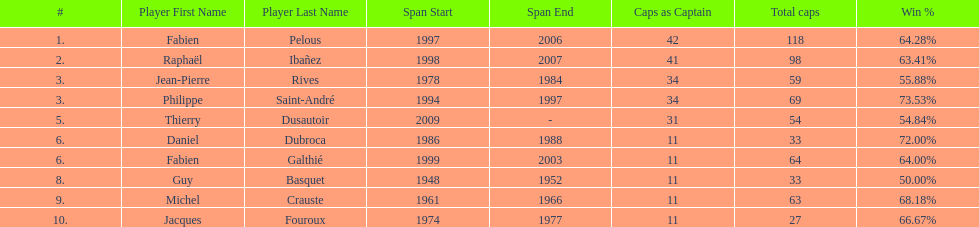Who had the largest win percentage? Philippe Saint-André. Give me the full table as a dictionary. {'header': ['#', 'Player First Name', 'Player Last Name', 'Span Start', 'Span End', 'Caps as Captain', 'Total caps', 'Win\xa0%'], 'rows': [['1.', 'Fabien', 'Pelous', '1997', '2006', '42', '118', '64.28%'], ['2.', 'Raphaël', 'Ibañez', '1998', '2007', '41', '98', '63.41%'], ['3.', 'Jean-Pierre', 'Rives', '1978', '1984', '34', '59', '55.88%'], ['3.', 'Philippe', 'Saint-André', '1994', '1997', '34', '69', '73.53%'], ['5.', 'Thierry', 'Dusautoir', '2009', '-', '31', '54', '54.84%'], ['6.', 'Daniel', 'Dubroca', '1986', '1988', '11', '33', '72.00%'], ['6.', 'Fabien', 'Galthié', '1999', '2003', '11', '64', '64.00%'], ['8.', 'Guy', 'Basquet', '1948', '1952', '11', '33', '50.00%'], ['9.', 'Michel', 'Crauste', '1961', '1966', '11', '63', '68.18%'], ['10.', 'Jacques', 'Fouroux', '1974', '1977', '11', '27', '66.67%']]} 